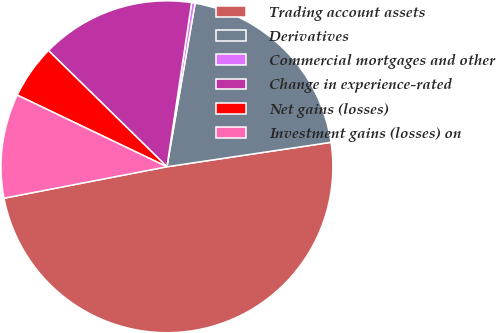<chart> <loc_0><loc_0><loc_500><loc_500><pie_chart><fcel>Trading account assets<fcel>Derivatives<fcel>Commercial mortgages and other<fcel>Change in experience-rated<fcel>Net gains (losses)<fcel>Investment gains (losses) on<nl><fcel>49.32%<fcel>19.93%<fcel>0.34%<fcel>15.03%<fcel>5.24%<fcel>10.14%<nl></chart> 